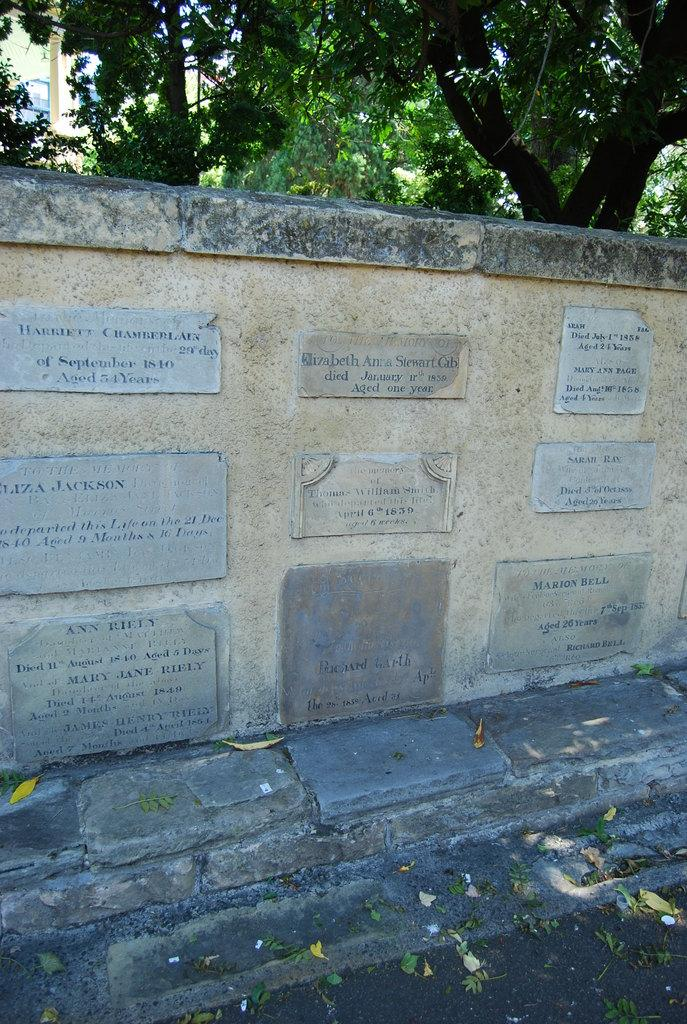What type of objects can be seen attached to a wall in the image? There are memorial stones in the image that are attached to a wall. What can be seen growing in the background of the image? There are trees with branches and leaves in the image. What type of trade is being conducted in the image? There is no trade being conducted in the image; it features memorial stones attached to a wall and trees with branches and leaves. What color is the hair of the person in the image? There is no person present in the image, so there is no hair to describe. 